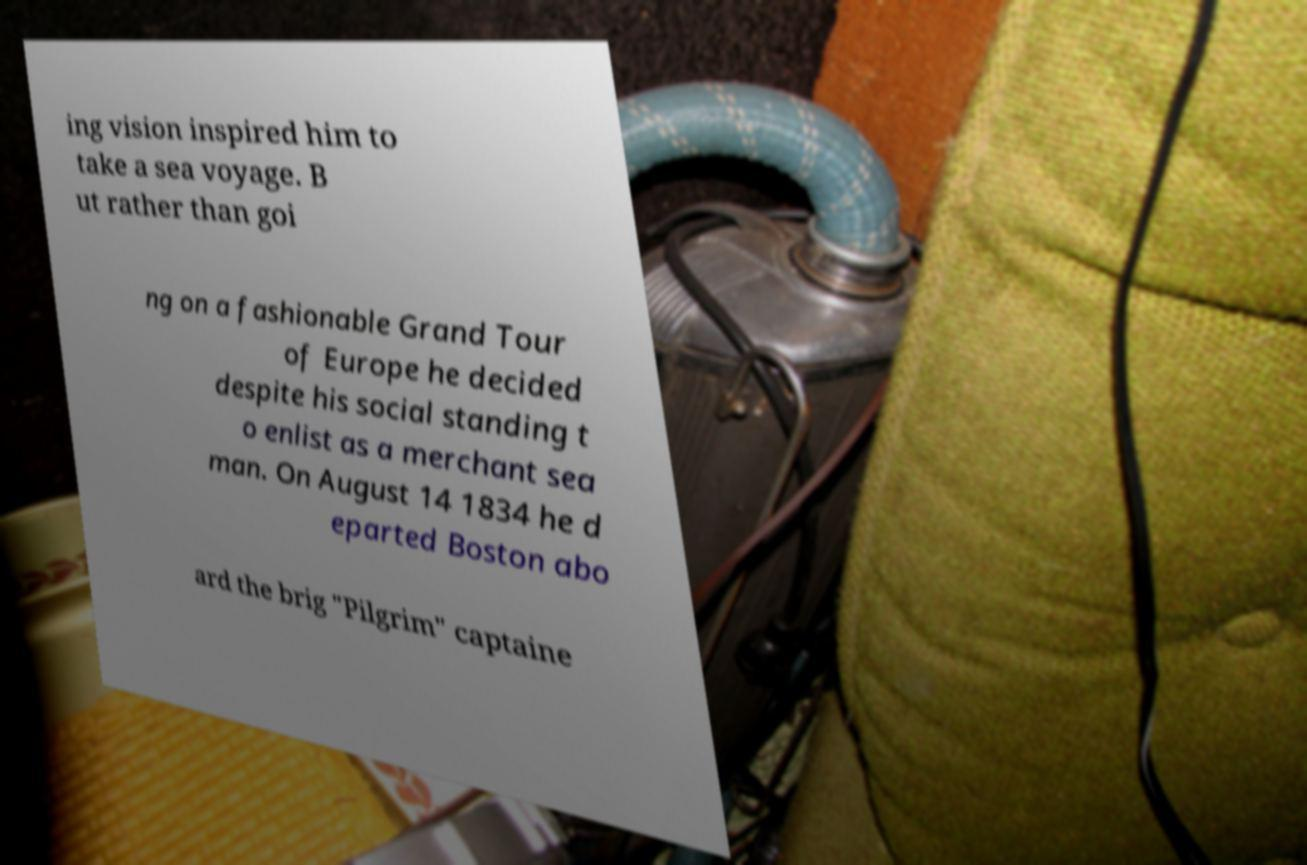Could you assist in decoding the text presented in this image and type it out clearly? ing vision inspired him to take a sea voyage. B ut rather than goi ng on a fashionable Grand Tour of Europe he decided despite his social standing t o enlist as a merchant sea man. On August 14 1834 he d eparted Boston abo ard the brig "Pilgrim" captaine 